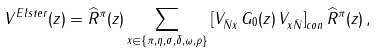<formula> <loc_0><loc_0><loc_500><loc_500>V ^ { E l s t e r } ( z ) = { \widehat { R } ^ { \pi } } ( z ) \sum _ { x \in \{ \pi , \eta , \sigma , \delta , \omega , \rho \} } \left [ V _ { { \bar { N } } x } \, G _ { 0 } ( z ) \, V _ { x { \bar { N } } } \right ] _ { c o n } { \widehat { R } ^ { \pi } } ( z ) \, ,</formula> 